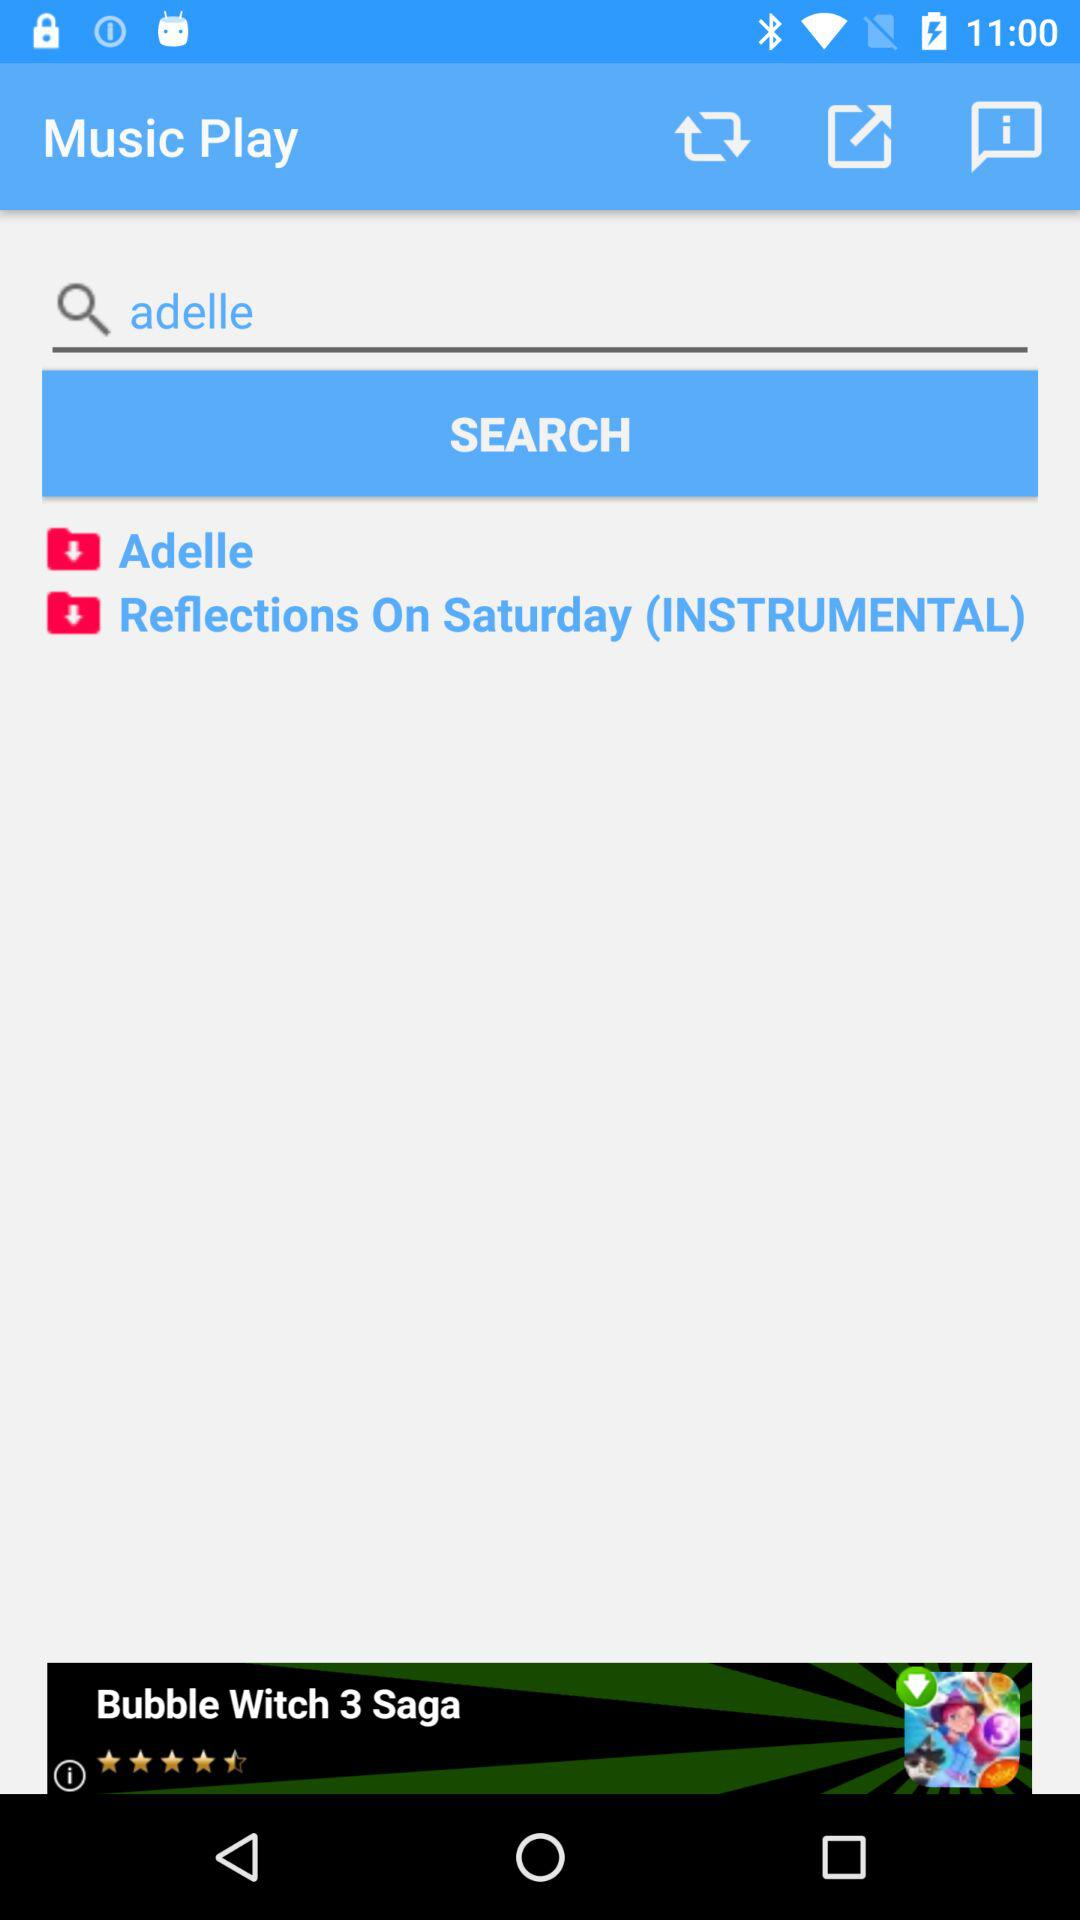What song is searched for in the search bar? The song is "adelle". 